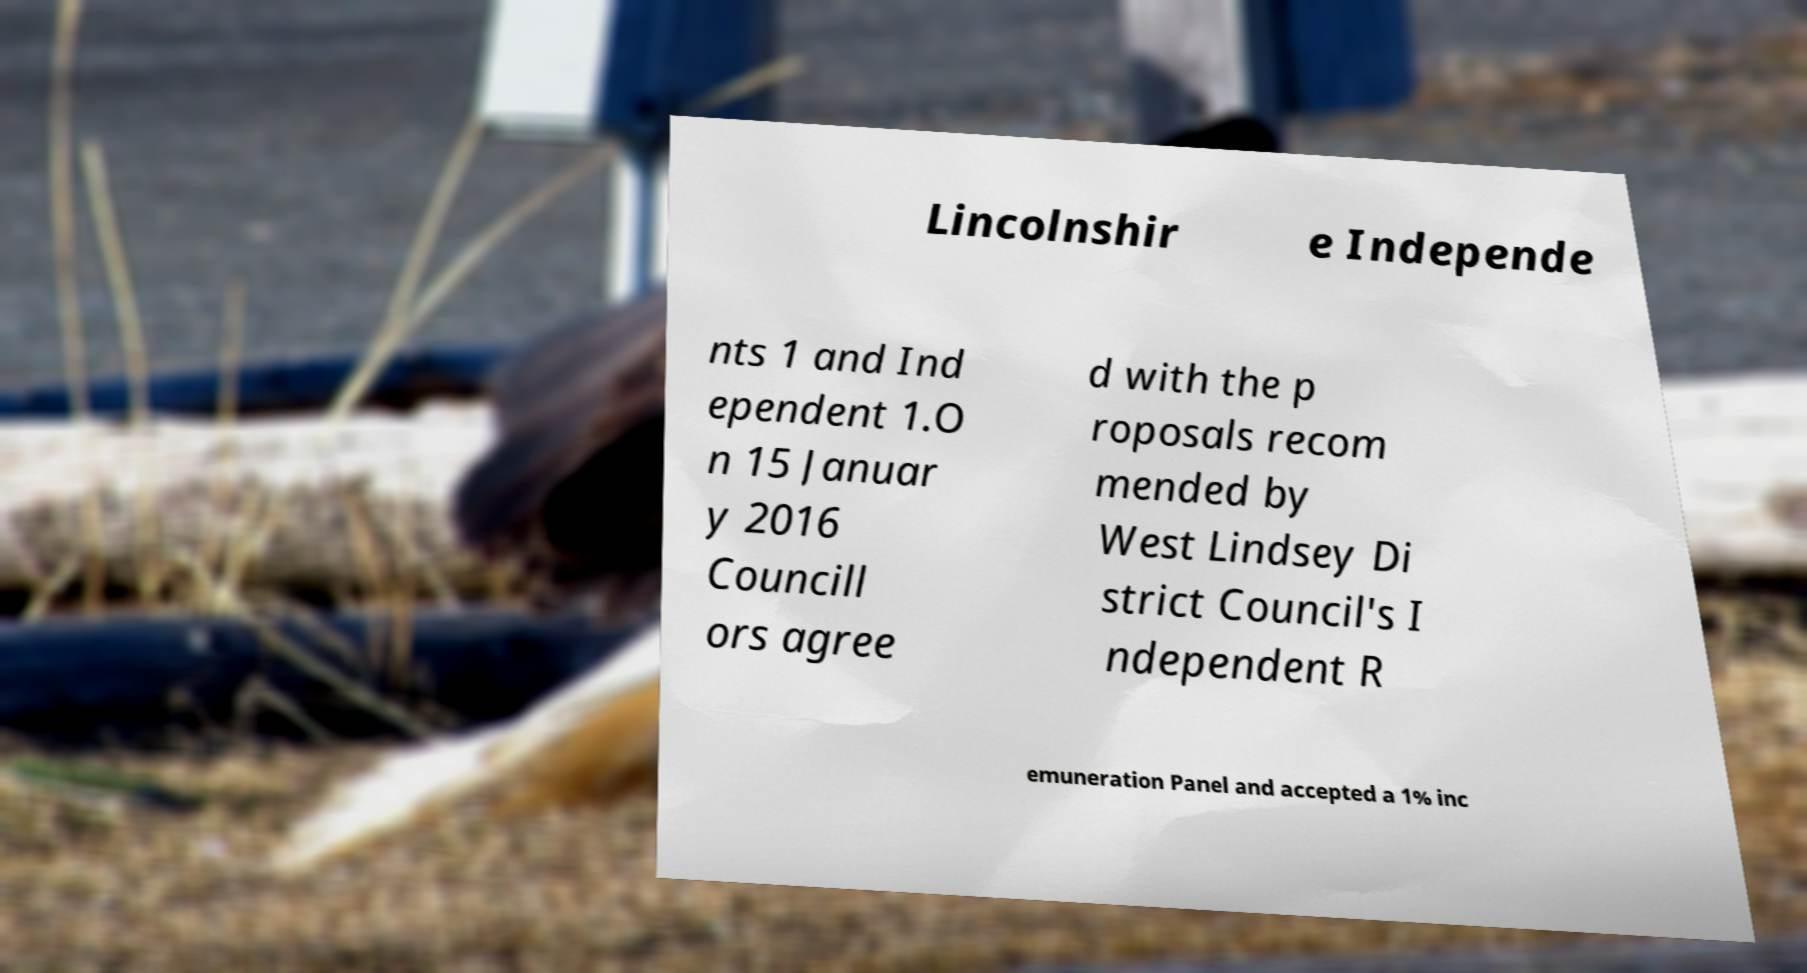Can you read and provide the text displayed in the image?This photo seems to have some interesting text. Can you extract and type it out for me? Lincolnshir e Independe nts 1 and Ind ependent 1.O n 15 Januar y 2016 Councill ors agree d with the p roposals recom mended by West Lindsey Di strict Council's I ndependent R emuneration Panel and accepted a 1% inc 